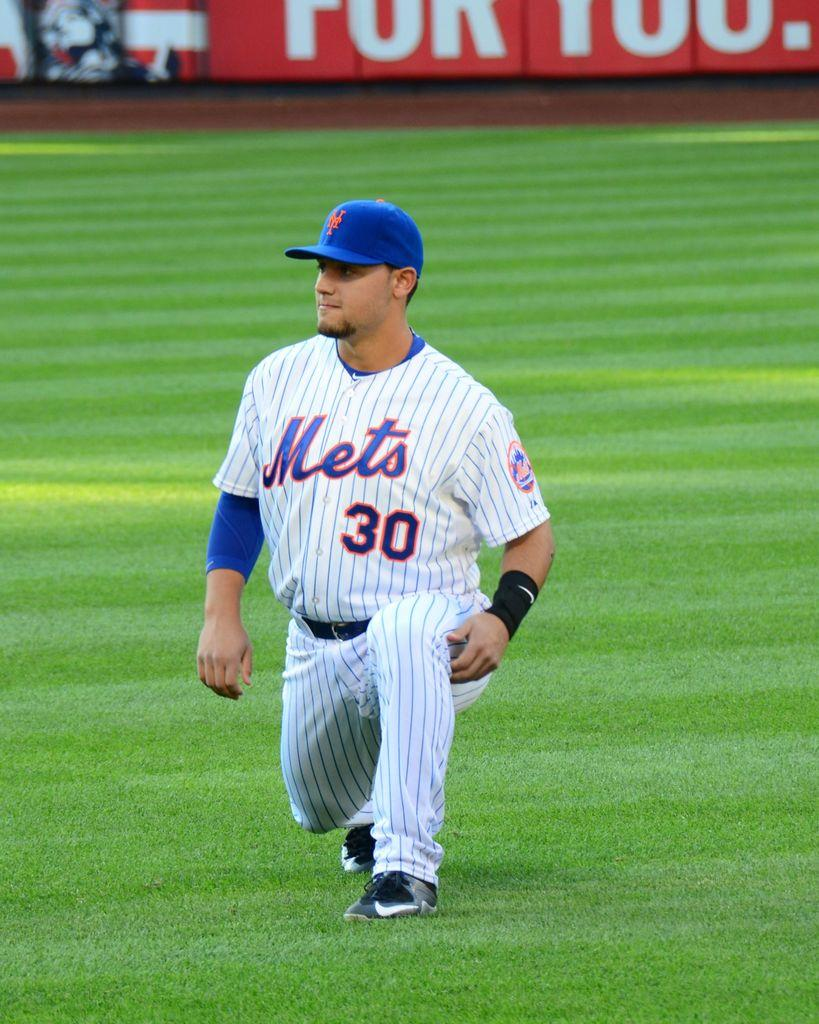<image>
Describe the image concisely. a Mets jersey on the player who is kneeling 